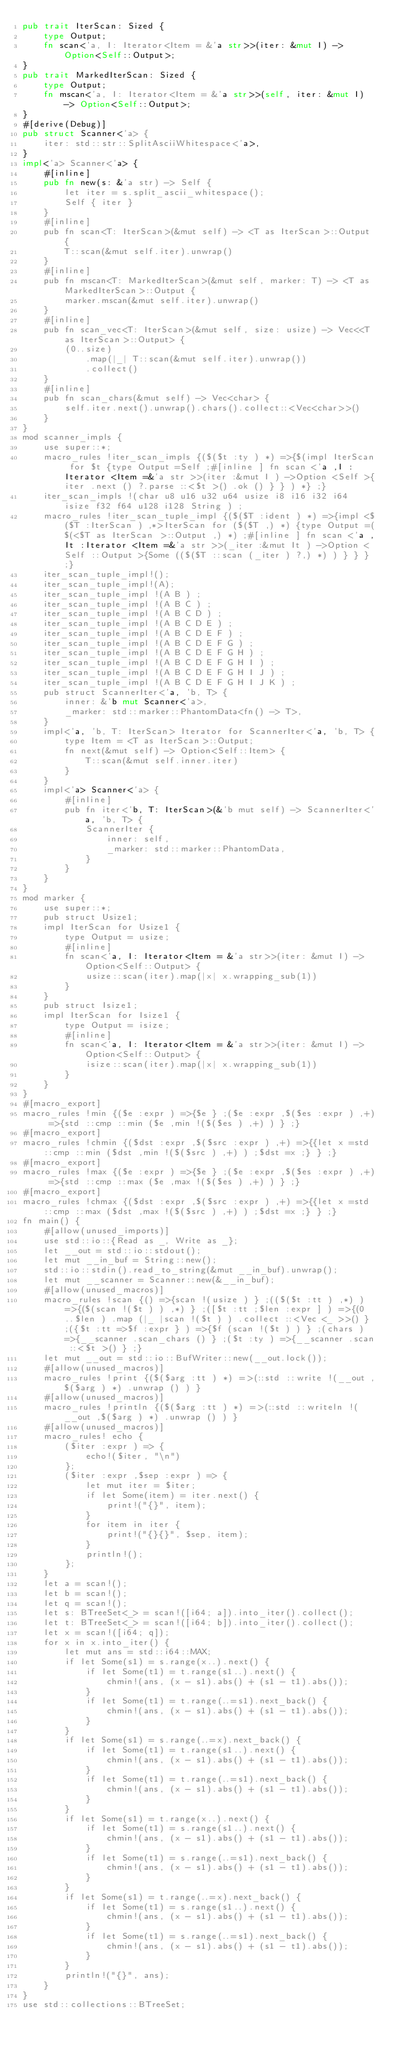Convert code to text. <code><loc_0><loc_0><loc_500><loc_500><_Rust_>pub trait IterScan: Sized {
    type Output;
    fn scan<'a, I: Iterator<Item = &'a str>>(iter: &mut I) -> Option<Self::Output>;
}
pub trait MarkedIterScan: Sized {
    type Output;
    fn mscan<'a, I: Iterator<Item = &'a str>>(self, iter: &mut I) -> Option<Self::Output>;
}
#[derive(Debug)]
pub struct Scanner<'a> {
    iter: std::str::SplitAsciiWhitespace<'a>,
}
impl<'a> Scanner<'a> {
    #[inline]
    pub fn new(s: &'a str) -> Self {
        let iter = s.split_ascii_whitespace();
        Self { iter }
    }
    #[inline]
    pub fn scan<T: IterScan>(&mut self) -> <T as IterScan>::Output {
        T::scan(&mut self.iter).unwrap()
    }
    #[inline]
    pub fn mscan<T: MarkedIterScan>(&mut self, marker: T) -> <T as MarkedIterScan>::Output {
        marker.mscan(&mut self.iter).unwrap()
    }
    #[inline]
    pub fn scan_vec<T: IterScan>(&mut self, size: usize) -> Vec<<T as IterScan>::Output> {
        (0..size)
            .map(|_| T::scan(&mut self.iter).unwrap())
            .collect()
    }
    #[inline]
    pub fn scan_chars(&mut self) -> Vec<char> {
        self.iter.next().unwrap().chars().collect::<Vec<char>>()
    }
}
mod scanner_impls {
    use super::*;
    macro_rules !iter_scan_impls {($($t :ty ) *) =>{$(impl IterScan for $t {type Output =Self ;#[inline ] fn scan <'a ,I :Iterator <Item =&'a str >>(iter :&mut I ) ->Option <Self >{iter .next () ?.parse ::<$t >() .ok () } } ) *} ;}
    iter_scan_impls !(char u8 u16 u32 u64 usize i8 i16 i32 i64 isize f32 f64 u128 i128 String ) ;
    macro_rules !iter_scan_tuple_impl {($($T :ident ) *) =>{impl <$($T :IterScan ) ,*>IterScan for ($($T ,) *) {type Output =($(<$T as IterScan >::Output ,) *) ;#[inline ] fn scan <'a ,It :Iterator <Item =&'a str >>(_iter :&mut It ) ->Option <Self ::Output >{Some (($($T ::scan (_iter ) ?,) *) ) } } } ;}
    iter_scan_tuple_impl!();
    iter_scan_tuple_impl!(A);
    iter_scan_tuple_impl !(A B ) ;
    iter_scan_tuple_impl !(A B C ) ;
    iter_scan_tuple_impl !(A B C D ) ;
    iter_scan_tuple_impl !(A B C D E ) ;
    iter_scan_tuple_impl !(A B C D E F ) ;
    iter_scan_tuple_impl !(A B C D E F G ) ;
    iter_scan_tuple_impl !(A B C D E F G H ) ;
    iter_scan_tuple_impl !(A B C D E F G H I ) ;
    iter_scan_tuple_impl !(A B C D E F G H I J ) ;
    iter_scan_tuple_impl !(A B C D E F G H I J K ) ;
    pub struct ScannerIter<'a, 'b, T> {
        inner: &'b mut Scanner<'a>,
        _marker: std::marker::PhantomData<fn() -> T>,
    }
    impl<'a, 'b, T: IterScan> Iterator for ScannerIter<'a, 'b, T> {
        type Item = <T as IterScan>::Output;
        fn next(&mut self) -> Option<Self::Item> {
            T::scan(&mut self.inner.iter)
        }
    }
    impl<'a> Scanner<'a> {
        #[inline]
        pub fn iter<'b, T: IterScan>(&'b mut self) -> ScannerIter<'a, 'b, T> {
            ScannerIter {
                inner: self,
                _marker: std::marker::PhantomData,
            }
        }
    }
}
mod marker {
    use super::*;
    pub struct Usize1;
    impl IterScan for Usize1 {
        type Output = usize;
        #[inline]
        fn scan<'a, I: Iterator<Item = &'a str>>(iter: &mut I) -> Option<Self::Output> {
            usize::scan(iter).map(|x| x.wrapping_sub(1))
        }
    }
    pub struct Isize1;
    impl IterScan for Isize1 {
        type Output = isize;
        #[inline]
        fn scan<'a, I: Iterator<Item = &'a str>>(iter: &mut I) -> Option<Self::Output> {
            isize::scan(iter).map(|x| x.wrapping_sub(1))
        }
    }
}
#[macro_export]
macro_rules !min {($e :expr ) =>{$e } ;($e :expr ,$($es :expr ) ,+) =>{std ::cmp ::min ($e ,min !($($es ) ,+) ) } ;}
#[macro_export]
macro_rules !chmin {($dst :expr ,$($src :expr ) ,+) =>{{let x =std ::cmp ::min ($dst ,min !($($src ) ,+) ) ;$dst =x ;} } ;}
#[macro_export]
macro_rules !max {($e :expr ) =>{$e } ;($e :expr ,$($es :expr ) ,+) =>{std ::cmp ::max ($e ,max !($($es ) ,+) ) } ;}
#[macro_export]
macro_rules !chmax {($dst :expr ,$($src :expr ) ,+) =>{{let x =std ::cmp ::max ($dst ,max !($($src ) ,+) ) ;$dst =x ;} } ;}
fn main() {
    #[allow(unused_imports)]
    use std::io::{Read as _, Write as _};
    let __out = std::io::stdout();
    let mut __in_buf = String::new();
    std::io::stdin().read_to_string(&mut __in_buf).unwrap();
    let mut __scanner = Scanner::new(&__in_buf);
    #[allow(unused_macros)]
    macro_rules !scan {() =>{scan !(usize ) } ;(($($t :tt ) ,*) ) =>{($(scan !($t ) ) ,*) } ;([$t :tt ;$len :expr ] ) =>{(0 ..$len ) .map (|_ |scan !($t ) ) .collect ::<Vec <_ >>() } ;({$t :tt =>$f :expr } ) =>{$f (scan !($t ) ) } ;(chars ) =>{__scanner .scan_chars () } ;($t :ty ) =>{__scanner .scan ::<$t >() } ;}
    let mut __out = std::io::BufWriter::new(__out.lock());
    #[allow(unused_macros)]
    macro_rules !print {($($arg :tt ) *) =>(::std ::write !(__out ,$($arg ) *) .unwrap () ) }
    #[allow(unused_macros)]
    macro_rules !println {($($arg :tt ) *) =>(::std ::writeln !(__out ,$($arg ) *) .unwrap () ) }
    #[allow(unused_macros)]
    macro_rules! echo {
        ($iter :expr ) => {
            echo!($iter, "\n")
        };
        ($iter :expr ,$sep :expr ) => {
            let mut iter = $iter;
            if let Some(item) = iter.next() {
                print!("{}", item);
            }
            for item in iter {
                print!("{}{}", $sep, item);
            }
            println!();
        };
    }
    let a = scan!();
    let b = scan!();
    let q = scan!();
    let s: BTreeSet<_> = scan!([i64; a]).into_iter().collect();
    let t: BTreeSet<_> = scan!([i64; b]).into_iter().collect();
    let x = scan!([i64; q]);
    for x in x.into_iter() {
        let mut ans = std::i64::MAX;
        if let Some(s1) = s.range(x..).next() {
            if let Some(t1) = t.range(s1..).next() {
                chmin!(ans, (x - s1).abs() + (s1 - t1).abs());
            }
            if let Some(t1) = t.range(..=s1).next_back() {
                chmin!(ans, (x - s1).abs() + (s1 - t1).abs());
            }
        }
        if let Some(s1) = s.range(..=x).next_back() {
            if let Some(t1) = t.range(s1..).next() {
                chmin!(ans, (x - s1).abs() + (s1 - t1).abs());
            }
            if let Some(t1) = t.range(..=s1).next_back() {
                chmin!(ans, (x - s1).abs() + (s1 - t1).abs());
            }
        }
        if let Some(s1) = t.range(x..).next() {
            if let Some(t1) = s.range(s1..).next() {
                chmin!(ans, (x - s1).abs() + (s1 - t1).abs());
            }
            if let Some(t1) = s.range(..=s1).next_back() {
                chmin!(ans, (x - s1).abs() + (s1 - t1).abs());
            }
        }
        if let Some(s1) = t.range(..=x).next_back() {
            if let Some(t1) = s.range(s1..).next() {
                chmin!(ans, (x - s1).abs() + (s1 - t1).abs());
            }
            if let Some(t1) = s.range(..=s1).next_back() {
                chmin!(ans, (x - s1).abs() + (s1 - t1).abs());
            }
        }
        println!("{}", ans);
    }
}
use std::collections::BTreeSet;</code> 